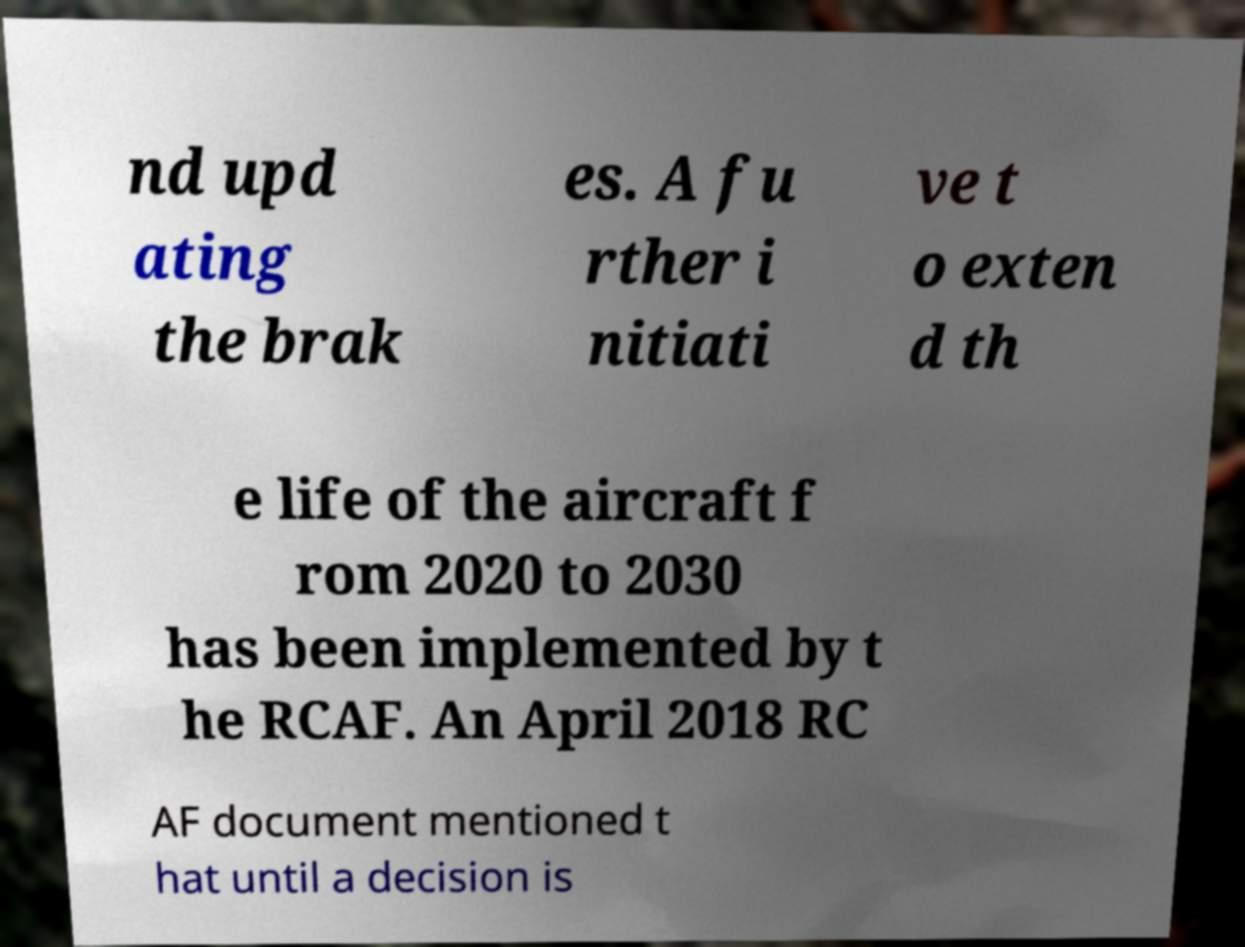For documentation purposes, I need the text within this image transcribed. Could you provide that? nd upd ating the brak es. A fu rther i nitiati ve t o exten d th e life of the aircraft f rom 2020 to 2030 has been implemented by t he RCAF. An April 2018 RC AF document mentioned t hat until a decision is 